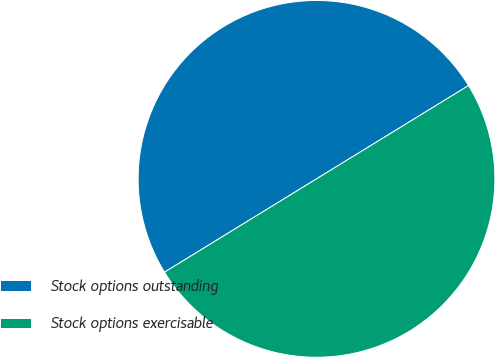Convert chart to OTSL. <chart><loc_0><loc_0><loc_500><loc_500><pie_chart><fcel>Stock options outstanding<fcel>Stock options exercisable<nl><fcel>50.0%<fcel>50.0%<nl></chart> 